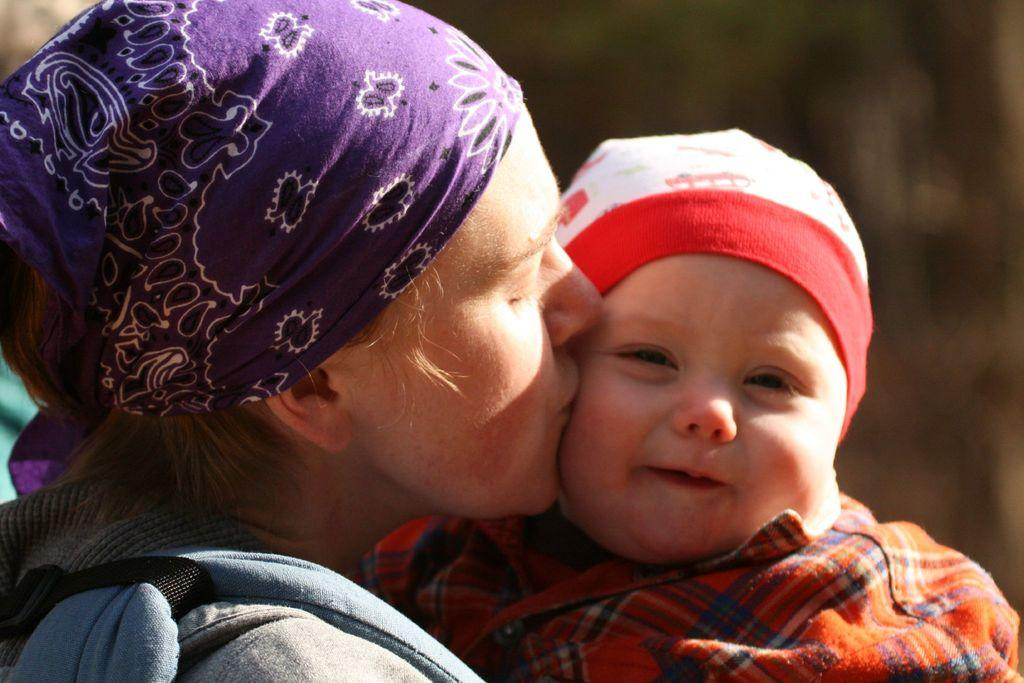Who is in the image? There is a person in the image. What is the person doing? The person is kissing a baby. How does the baby appear to feel about the interaction? The baby is smiling. Can you describe the background of the image? The background of the image is blurred. How many boys are playing with balls in the image? There are no boys or balls present in the image. Is there a veil visible in the image? There is no veil present in the image. 